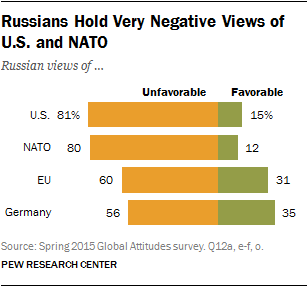Give some essential details in this illustration. The favorable value of the European Union is not greater than that of Germany. The number of bar shows that are more than 60 in unfavorable conditions is 2. 